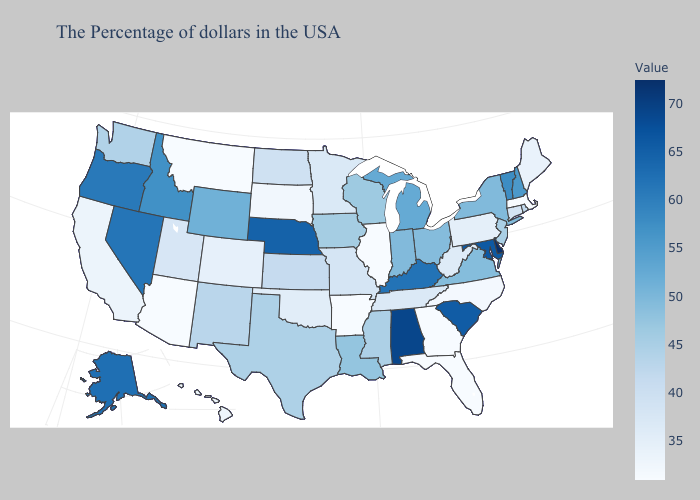Does Missouri have a higher value than South Dakota?
Concise answer only. Yes. Does Delaware have the highest value in the USA?
Be succinct. Yes. Among the states that border Missouri , which have the highest value?
Keep it brief. Nebraska. Which states hav the highest value in the Northeast?
Concise answer only. Vermont. Does Pennsylvania have the highest value in the Northeast?
Keep it brief. No. Among the states that border Texas , does Arkansas have the lowest value?
Answer briefly. Yes. 